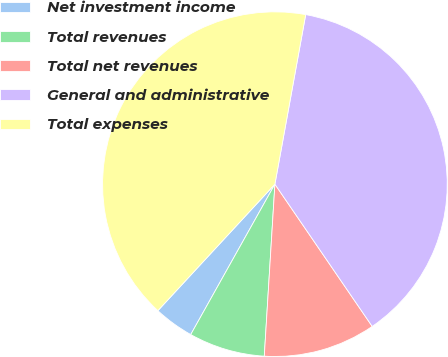<chart> <loc_0><loc_0><loc_500><loc_500><pie_chart><fcel>Net investment income<fcel>Total revenues<fcel>Total net revenues<fcel>General and administrative<fcel>Total expenses<nl><fcel>3.76%<fcel>7.14%<fcel>10.53%<fcel>37.59%<fcel>40.98%<nl></chart> 